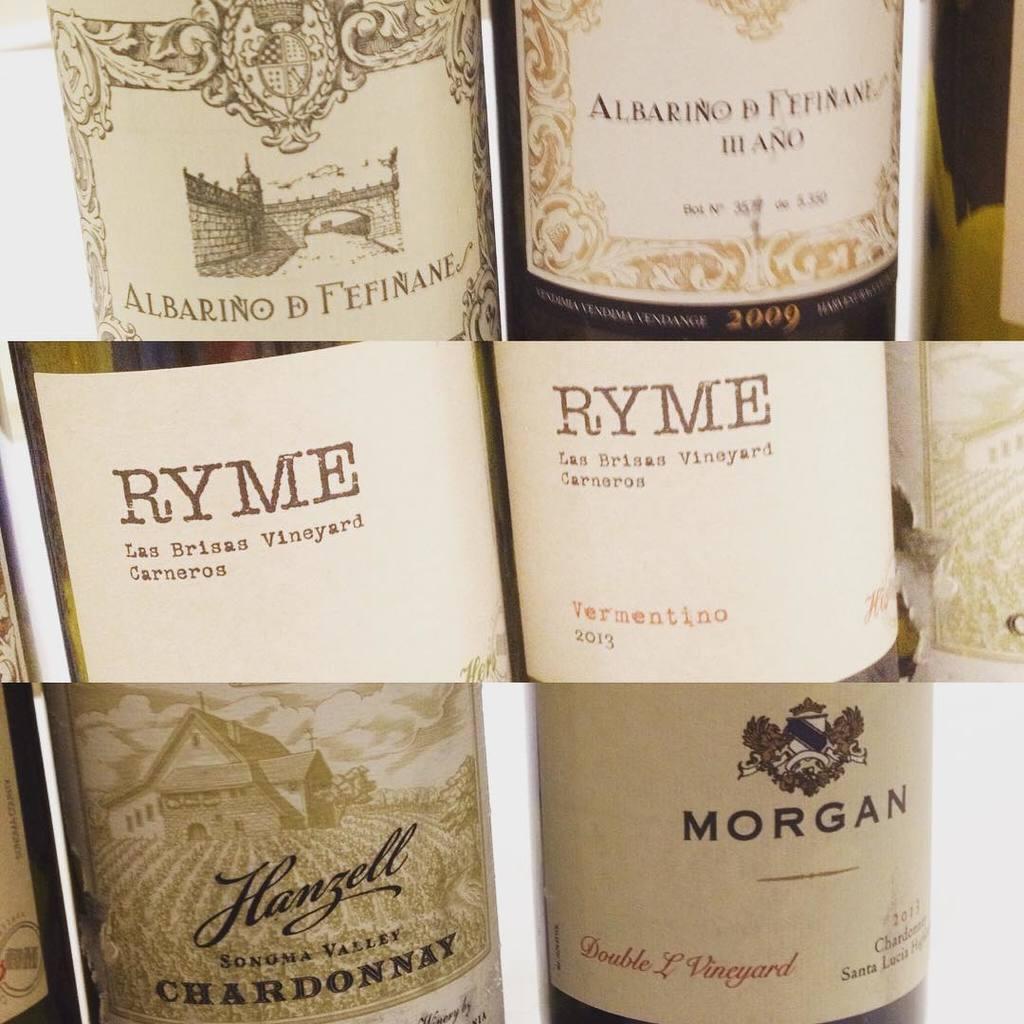What is the name of the middle row wine?
Your answer should be compact. Ryme. 